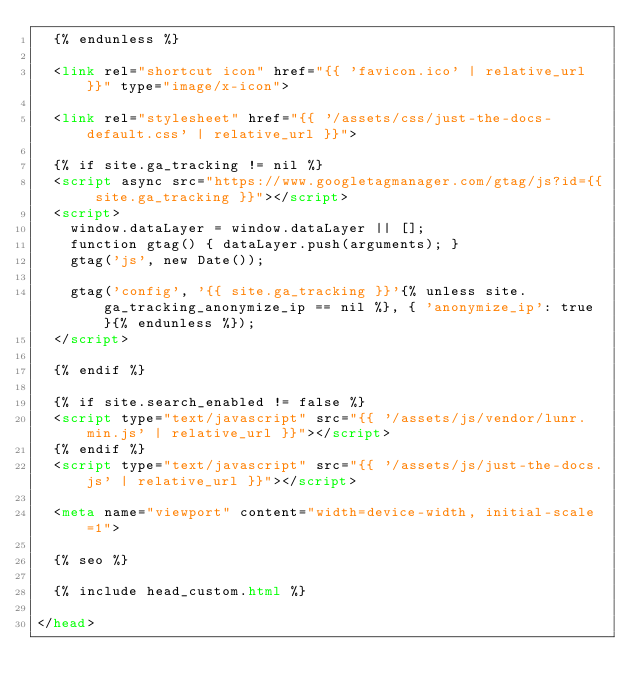Convert code to text. <code><loc_0><loc_0><loc_500><loc_500><_HTML_>  {% endunless %}

  <link rel="shortcut icon" href="{{ 'favicon.ico' | relative_url }}" type="image/x-icon">

  <link rel="stylesheet" href="{{ '/assets/css/just-the-docs-default.css' | relative_url }}">

  {% if site.ga_tracking != nil %}
  <script async src="https://www.googletagmanager.com/gtag/js?id={{ site.ga_tracking }}"></script>
  <script>
    window.dataLayer = window.dataLayer || [];
    function gtag() { dataLayer.push(arguments); }
    gtag('js', new Date());

    gtag('config', '{{ site.ga_tracking }}'{% unless site.ga_tracking_anonymize_ip == nil %}, { 'anonymize_ip': true }{% endunless %});
  </script>

  {% endif %}

  {% if site.search_enabled != false %}
  <script type="text/javascript" src="{{ '/assets/js/vendor/lunr.min.js' | relative_url }}"></script>
  {% endif %}
  <script type="text/javascript" src="{{ '/assets/js/just-the-docs.js' | relative_url }}"></script>

  <meta name="viewport" content="width=device-width, initial-scale=1">

  {% seo %}

  {% include head_custom.html %}

</head></code> 